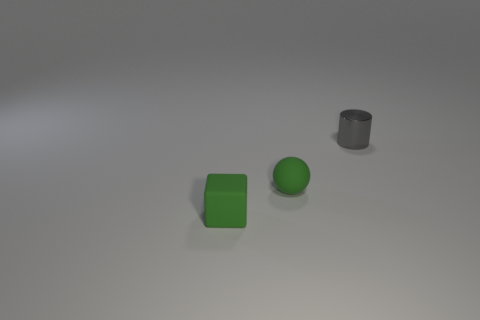What number of other objects are there of the same shape as the tiny metal thing?
Your response must be concise. 0. Are there more gray metallic cylinders than small brown rubber cylinders?
Your answer should be very brief. Yes. There is a green matte thing behind the tiny green block in front of the matte thing that is behind the tiny green matte block; how big is it?
Your response must be concise. Small. There is a green rubber thing that is on the right side of the small cube; how big is it?
Your response must be concise. Small. How many objects are big red metallic cubes or things in front of the metallic cylinder?
Ensure brevity in your answer.  2. How many other things are there of the same size as the cylinder?
Give a very brief answer. 2. Is the number of green spheres in front of the green matte cube greater than the number of tiny green spheres?
Offer a very short reply. No. Is there any other thing of the same color as the metallic cylinder?
Ensure brevity in your answer.  No. What is the shape of the green thing that is made of the same material as the tiny green sphere?
Provide a short and direct response. Cube. Is the thing behind the green ball made of the same material as the green sphere?
Ensure brevity in your answer.  No. 